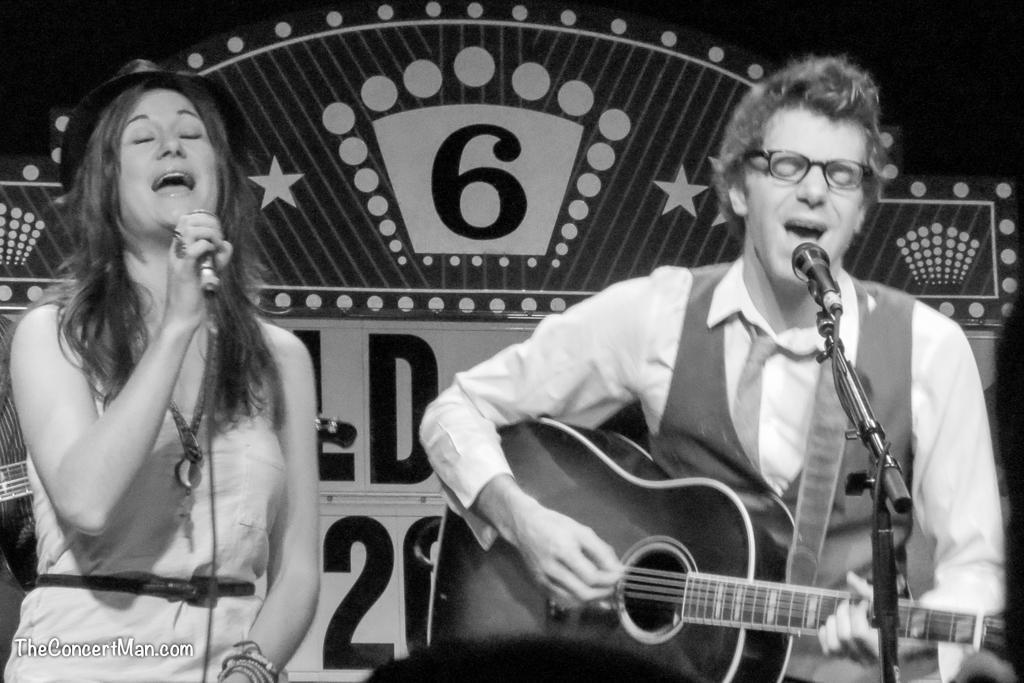How would you summarize this image in a sentence or two? In this image I see a woman who is holding the mic and I also see a man who is holding the guitar and is in front of the pic. 